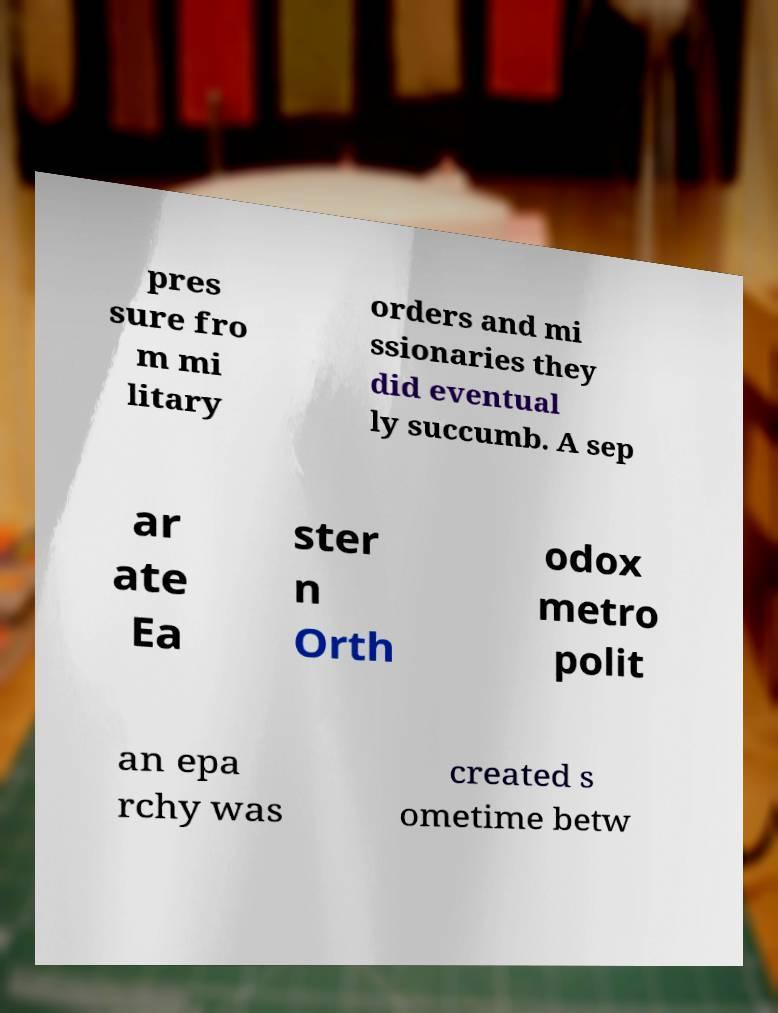I need the written content from this picture converted into text. Can you do that? pres sure fro m mi litary orders and mi ssionaries they did eventual ly succumb. A sep ar ate Ea ster n Orth odox metro polit an epa rchy was created s ometime betw 